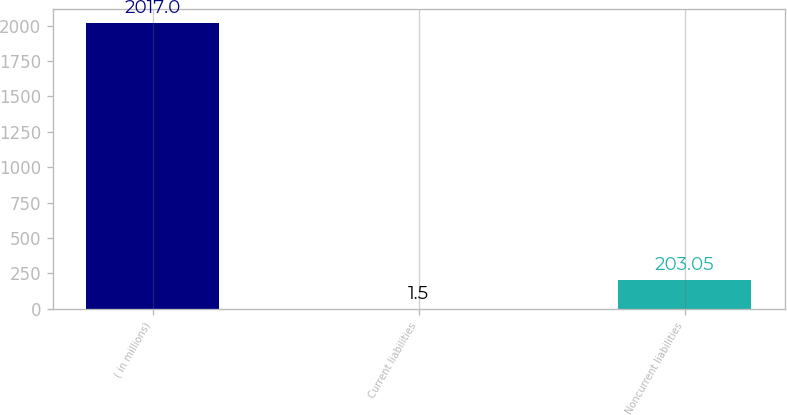Convert chart. <chart><loc_0><loc_0><loc_500><loc_500><bar_chart><fcel>( in millions)<fcel>Current liabilities<fcel>Noncurrent liabilities<nl><fcel>2017<fcel>1.5<fcel>203.05<nl></chart> 